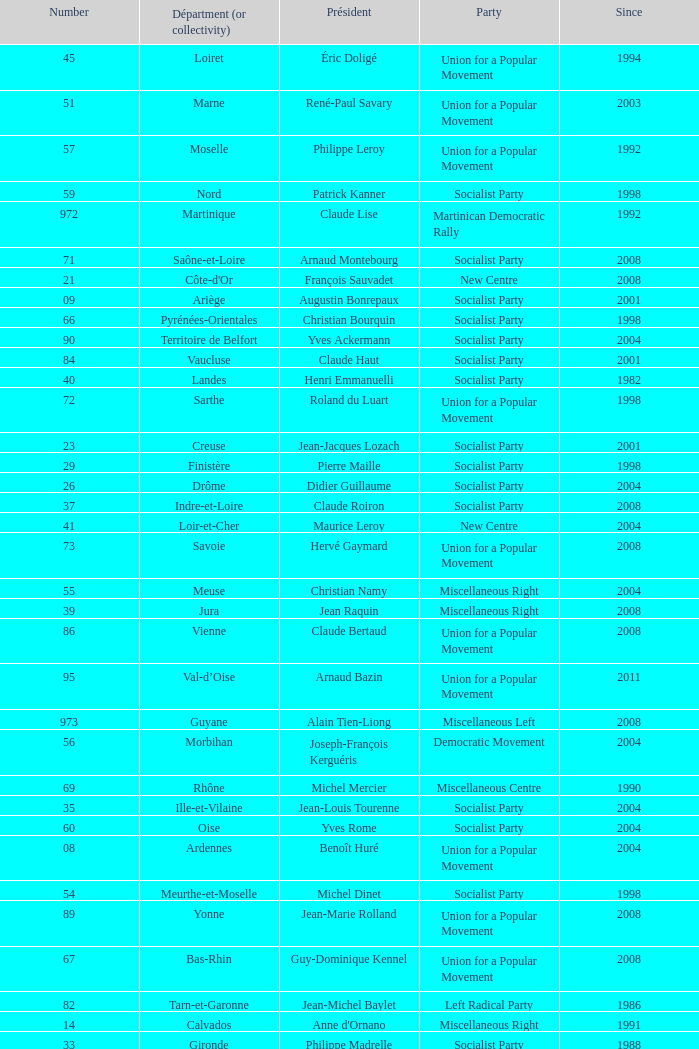Who is the president from the Union for a Popular Movement party that represents the Hautes-Alpes department? Jean-Yves Dusserre. 